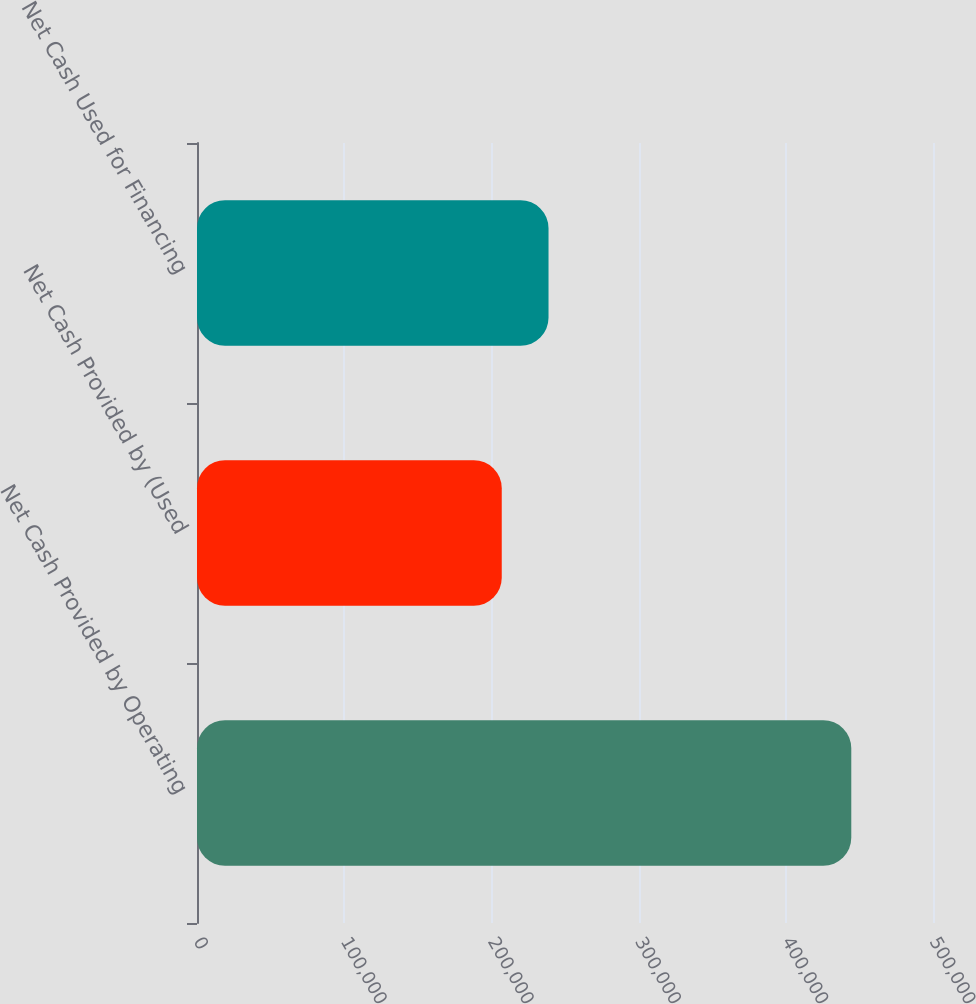<chart> <loc_0><loc_0><loc_500><loc_500><bar_chart><fcel>Net Cash Provided by Operating<fcel>Net Cash Provided by (Used<fcel>Net Cash Used for Financing<nl><fcel>444487<fcel>207031<fcel>238809<nl></chart> 